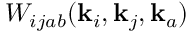Convert formula to latex. <formula><loc_0><loc_0><loc_500><loc_500>W _ { i j a b } ( k _ { i } , k _ { j } , k _ { a } )</formula> 